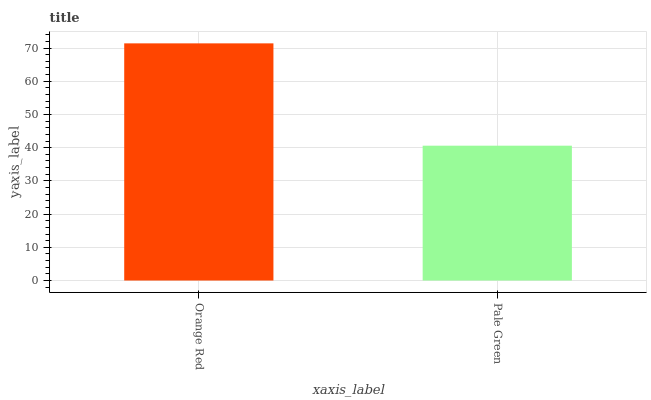Is Pale Green the minimum?
Answer yes or no. Yes. Is Orange Red the maximum?
Answer yes or no. Yes. Is Pale Green the maximum?
Answer yes or no. No. Is Orange Red greater than Pale Green?
Answer yes or no. Yes. Is Pale Green less than Orange Red?
Answer yes or no. Yes. Is Pale Green greater than Orange Red?
Answer yes or no. No. Is Orange Red less than Pale Green?
Answer yes or no. No. Is Orange Red the high median?
Answer yes or no. Yes. Is Pale Green the low median?
Answer yes or no. Yes. Is Pale Green the high median?
Answer yes or no. No. Is Orange Red the low median?
Answer yes or no. No. 